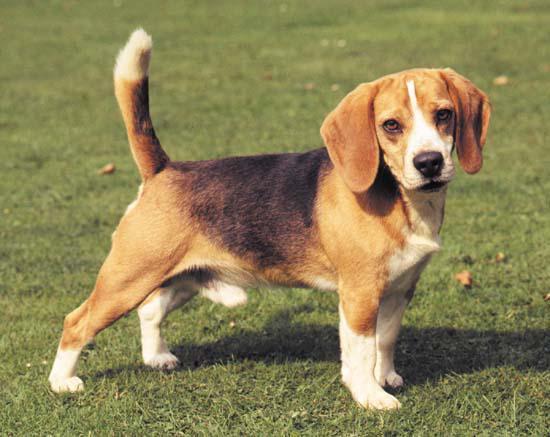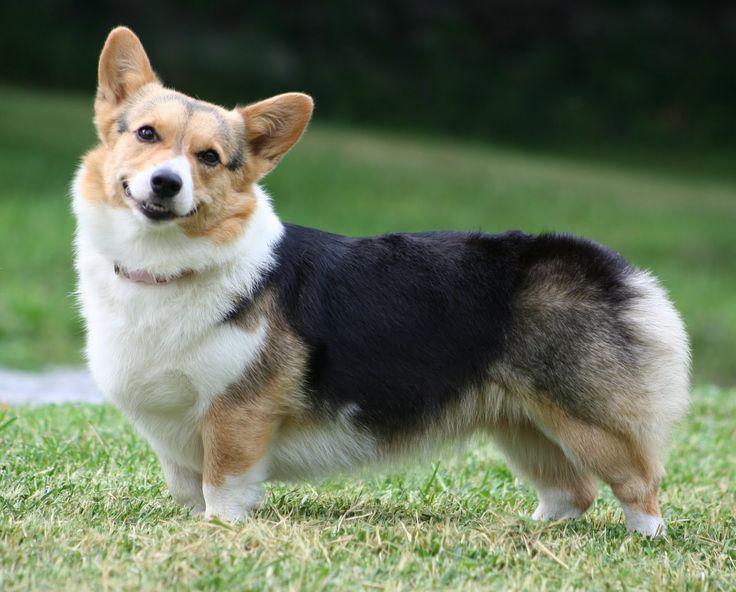The first image is the image on the left, the second image is the image on the right. Examine the images to the left and right. Is the description "there is at least one dog with dog tags in the image pair" accurate? Answer yes or no. No. The first image is the image on the left, the second image is the image on the right. For the images shown, is this caption "Exactly one dog is pointed to the right." true? Answer yes or no. Yes. 